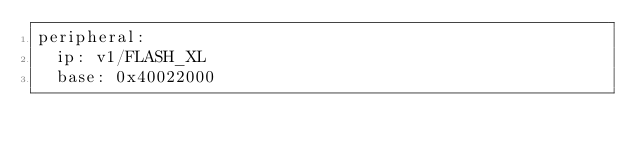<code> <loc_0><loc_0><loc_500><loc_500><_YAML_>peripheral:
  ip: v1/FLASH_XL
  base: 0x40022000
</code> 